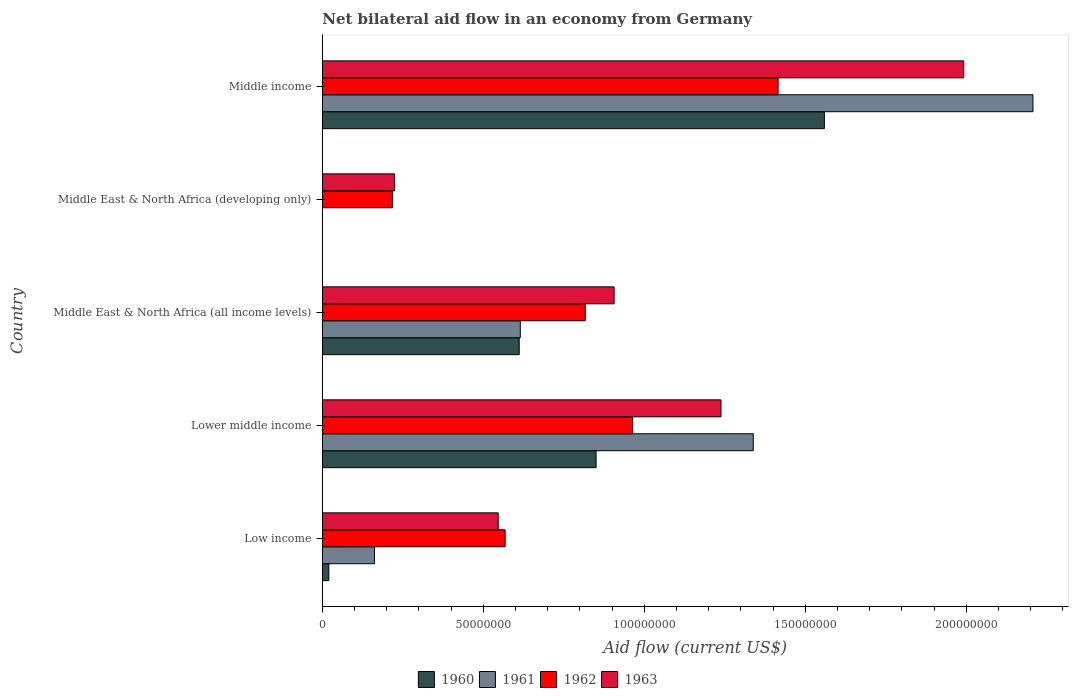How many groups of bars are there?
Offer a terse response. 5. Are the number of bars per tick equal to the number of legend labels?
Offer a terse response. No. Are the number of bars on each tick of the Y-axis equal?
Provide a short and direct response. No. In how many cases, is the number of bars for a given country not equal to the number of legend labels?
Keep it short and to the point. 1. What is the net bilateral aid flow in 1960 in Middle income?
Your answer should be very brief. 1.56e+08. Across all countries, what is the maximum net bilateral aid flow in 1960?
Offer a very short reply. 1.56e+08. Across all countries, what is the minimum net bilateral aid flow in 1963?
Offer a very short reply. 2.24e+07. In which country was the net bilateral aid flow in 1960 maximum?
Provide a succinct answer. Middle income. What is the total net bilateral aid flow in 1961 in the graph?
Offer a terse response. 4.32e+08. What is the difference between the net bilateral aid flow in 1962 in Low income and that in Middle income?
Your answer should be compact. -8.48e+07. What is the difference between the net bilateral aid flow in 1961 in Lower middle income and the net bilateral aid flow in 1963 in Low income?
Provide a short and direct response. 7.92e+07. What is the average net bilateral aid flow in 1962 per country?
Offer a terse response. 7.96e+07. What is the difference between the net bilateral aid flow in 1962 and net bilateral aid flow in 1960 in Middle East & North Africa (all income levels)?
Make the answer very short. 2.05e+07. What is the ratio of the net bilateral aid flow in 1960 in Lower middle income to that in Middle East & North Africa (all income levels)?
Provide a short and direct response. 1.39. Is the difference between the net bilateral aid flow in 1962 in Lower middle income and Middle East & North Africa (all income levels) greater than the difference between the net bilateral aid flow in 1960 in Lower middle income and Middle East & North Africa (all income levels)?
Offer a terse response. No. What is the difference between the highest and the second highest net bilateral aid flow in 1962?
Give a very brief answer. 4.52e+07. What is the difference between the highest and the lowest net bilateral aid flow in 1963?
Give a very brief answer. 1.77e+08. In how many countries, is the net bilateral aid flow in 1963 greater than the average net bilateral aid flow in 1963 taken over all countries?
Make the answer very short. 2. Is the sum of the net bilateral aid flow in 1962 in Low income and Middle East & North Africa (all income levels) greater than the maximum net bilateral aid flow in 1960 across all countries?
Provide a succinct answer. No. Is it the case that in every country, the sum of the net bilateral aid flow in 1961 and net bilateral aid flow in 1962 is greater than the sum of net bilateral aid flow in 1960 and net bilateral aid flow in 1963?
Give a very brief answer. No. Is it the case that in every country, the sum of the net bilateral aid flow in 1960 and net bilateral aid flow in 1962 is greater than the net bilateral aid flow in 1961?
Provide a succinct answer. Yes. Are all the bars in the graph horizontal?
Ensure brevity in your answer.  Yes. What is the difference between two consecutive major ticks on the X-axis?
Your response must be concise. 5.00e+07. Where does the legend appear in the graph?
Your answer should be very brief. Bottom center. How many legend labels are there?
Offer a terse response. 4. How are the legend labels stacked?
Your response must be concise. Horizontal. What is the title of the graph?
Make the answer very short. Net bilateral aid flow in an economy from Germany. Does "1995" appear as one of the legend labels in the graph?
Give a very brief answer. No. What is the label or title of the X-axis?
Your answer should be compact. Aid flow (current US$). What is the Aid flow (current US$) in 1960 in Low income?
Your answer should be very brief. 2.02e+06. What is the Aid flow (current US$) of 1961 in Low income?
Ensure brevity in your answer.  1.62e+07. What is the Aid flow (current US$) in 1962 in Low income?
Ensure brevity in your answer.  5.68e+07. What is the Aid flow (current US$) of 1963 in Low income?
Offer a very short reply. 5.46e+07. What is the Aid flow (current US$) in 1960 in Lower middle income?
Your answer should be compact. 8.50e+07. What is the Aid flow (current US$) in 1961 in Lower middle income?
Your answer should be compact. 1.34e+08. What is the Aid flow (current US$) of 1962 in Lower middle income?
Your response must be concise. 9.64e+07. What is the Aid flow (current US$) of 1963 in Lower middle income?
Your answer should be compact. 1.24e+08. What is the Aid flow (current US$) in 1960 in Middle East & North Africa (all income levels)?
Your response must be concise. 6.11e+07. What is the Aid flow (current US$) in 1961 in Middle East & North Africa (all income levels)?
Make the answer very short. 6.15e+07. What is the Aid flow (current US$) in 1962 in Middle East & North Africa (all income levels)?
Offer a terse response. 8.16e+07. What is the Aid flow (current US$) of 1963 in Middle East & North Africa (all income levels)?
Make the answer very short. 9.06e+07. What is the Aid flow (current US$) of 1962 in Middle East & North Africa (developing only)?
Ensure brevity in your answer.  2.18e+07. What is the Aid flow (current US$) in 1963 in Middle East & North Africa (developing only)?
Provide a succinct answer. 2.24e+07. What is the Aid flow (current US$) of 1960 in Middle income?
Give a very brief answer. 1.56e+08. What is the Aid flow (current US$) of 1961 in Middle income?
Provide a succinct answer. 2.21e+08. What is the Aid flow (current US$) of 1962 in Middle income?
Provide a succinct answer. 1.42e+08. What is the Aid flow (current US$) of 1963 in Middle income?
Provide a short and direct response. 1.99e+08. Across all countries, what is the maximum Aid flow (current US$) in 1960?
Provide a succinct answer. 1.56e+08. Across all countries, what is the maximum Aid flow (current US$) in 1961?
Make the answer very short. 2.21e+08. Across all countries, what is the maximum Aid flow (current US$) of 1962?
Keep it short and to the point. 1.42e+08. Across all countries, what is the maximum Aid flow (current US$) in 1963?
Make the answer very short. 1.99e+08. Across all countries, what is the minimum Aid flow (current US$) of 1960?
Make the answer very short. 0. Across all countries, what is the minimum Aid flow (current US$) of 1961?
Offer a terse response. 0. Across all countries, what is the minimum Aid flow (current US$) of 1962?
Your response must be concise. 2.18e+07. Across all countries, what is the minimum Aid flow (current US$) of 1963?
Keep it short and to the point. 2.24e+07. What is the total Aid flow (current US$) of 1960 in the graph?
Offer a terse response. 3.04e+08. What is the total Aid flow (current US$) in 1961 in the graph?
Provide a succinct answer. 4.32e+08. What is the total Aid flow (current US$) of 1962 in the graph?
Give a very brief answer. 3.98e+08. What is the total Aid flow (current US$) of 1963 in the graph?
Provide a short and direct response. 4.91e+08. What is the difference between the Aid flow (current US$) in 1960 in Low income and that in Lower middle income?
Provide a succinct answer. -8.30e+07. What is the difference between the Aid flow (current US$) in 1961 in Low income and that in Lower middle income?
Your response must be concise. -1.18e+08. What is the difference between the Aid flow (current US$) in 1962 in Low income and that in Lower middle income?
Offer a very short reply. -3.96e+07. What is the difference between the Aid flow (current US$) in 1963 in Low income and that in Lower middle income?
Offer a very short reply. -6.92e+07. What is the difference between the Aid flow (current US$) of 1960 in Low income and that in Middle East & North Africa (all income levels)?
Provide a succinct answer. -5.91e+07. What is the difference between the Aid flow (current US$) in 1961 in Low income and that in Middle East & North Africa (all income levels)?
Your response must be concise. -4.53e+07. What is the difference between the Aid flow (current US$) in 1962 in Low income and that in Middle East & North Africa (all income levels)?
Give a very brief answer. -2.49e+07. What is the difference between the Aid flow (current US$) in 1963 in Low income and that in Middle East & North Africa (all income levels)?
Make the answer very short. -3.60e+07. What is the difference between the Aid flow (current US$) of 1962 in Low income and that in Middle East & North Africa (developing only)?
Provide a succinct answer. 3.50e+07. What is the difference between the Aid flow (current US$) in 1963 in Low income and that in Middle East & North Africa (developing only)?
Provide a succinct answer. 3.22e+07. What is the difference between the Aid flow (current US$) of 1960 in Low income and that in Middle income?
Your answer should be compact. -1.54e+08. What is the difference between the Aid flow (current US$) of 1961 in Low income and that in Middle income?
Your answer should be compact. -2.04e+08. What is the difference between the Aid flow (current US$) in 1962 in Low income and that in Middle income?
Provide a succinct answer. -8.48e+07. What is the difference between the Aid flow (current US$) of 1963 in Low income and that in Middle income?
Make the answer very short. -1.45e+08. What is the difference between the Aid flow (current US$) of 1960 in Lower middle income and that in Middle East & North Africa (all income levels)?
Provide a short and direct response. 2.39e+07. What is the difference between the Aid flow (current US$) of 1961 in Lower middle income and that in Middle East & North Africa (all income levels)?
Offer a very short reply. 7.24e+07. What is the difference between the Aid flow (current US$) of 1962 in Lower middle income and that in Middle East & North Africa (all income levels)?
Provide a short and direct response. 1.47e+07. What is the difference between the Aid flow (current US$) of 1963 in Lower middle income and that in Middle East & North Africa (all income levels)?
Provide a short and direct response. 3.32e+07. What is the difference between the Aid flow (current US$) of 1962 in Lower middle income and that in Middle East & North Africa (developing only)?
Offer a very short reply. 7.46e+07. What is the difference between the Aid flow (current US$) in 1963 in Lower middle income and that in Middle East & North Africa (developing only)?
Offer a terse response. 1.01e+08. What is the difference between the Aid flow (current US$) of 1960 in Lower middle income and that in Middle income?
Ensure brevity in your answer.  -7.09e+07. What is the difference between the Aid flow (current US$) of 1961 in Lower middle income and that in Middle income?
Your answer should be very brief. -8.69e+07. What is the difference between the Aid flow (current US$) in 1962 in Lower middle income and that in Middle income?
Your response must be concise. -4.52e+07. What is the difference between the Aid flow (current US$) of 1963 in Lower middle income and that in Middle income?
Offer a terse response. -7.54e+07. What is the difference between the Aid flow (current US$) in 1962 in Middle East & North Africa (all income levels) and that in Middle East & North Africa (developing only)?
Your answer should be compact. 5.99e+07. What is the difference between the Aid flow (current US$) of 1963 in Middle East & North Africa (all income levels) and that in Middle East & North Africa (developing only)?
Your answer should be very brief. 6.82e+07. What is the difference between the Aid flow (current US$) in 1960 in Middle East & North Africa (all income levels) and that in Middle income?
Your answer should be very brief. -9.48e+07. What is the difference between the Aid flow (current US$) of 1961 in Middle East & North Africa (all income levels) and that in Middle income?
Offer a terse response. -1.59e+08. What is the difference between the Aid flow (current US$) in 1962 in Middle East & North Africa (all income levels) and that in Middle income?
Provide a succinct answer. -5.99e+07. What is the difference between the Aid flow (current US$) of 1963 in Middle East & North Africa (all income levels) and that in Middle income?
Your answer should be very brief. -1.09e+08. What is the difference between the Aid flow (current US$) in 1962 in Middle East & North Africa (developing only) and that in Middle income?
Your answer should be very brief. -1.20e+08. What is the difference between the Aid flow (current US$) in 1963 in Middle East & North Africa (developing only) and that in Middle income?
Ensure brevity in your answer.  -1.77e+08. What is the difference between the Aid flow (current US$) in 1960 in Low income and the Aid flow (current US$) in 1961 in Lower middle income?
Keep it short and to the point. -1.32e+08. What is the difference between the Aid flow (current US$) of 1960 in Low income and the Aid flow (current US$) of 1962 in Lower middle income?
Give a very brief answer. -9.43e+07. What is the difference between the Aid flow (current US$) in 1960 in Low income and the Aid flow (current US$) in 1963 in Lower middle income?
Provide a short and direct response. -1.22e+08. What is the difference between the Aid flow (current US$) of 1961 in Low income and the Aid flow (current US$) of 1962 in Lower middle income?
Make the answer very short. -8.02e+07. What is the difference between the Aid flow (current US$) of 1961 in Low income and the Aid flow (current US$) of 1963 in Lower middle income?
Make the answer very short. -1.08e+08. What is the difference between the Aid flow (current US$) in 1962 in Low income and the Aid flow (current US$) in 1963 in Lower middle income?
Offer a very short reply. -6.70e+07. What is the difference between the Aid flow (current US$) in 1960 in Low income and the Aid flow (current US$) in 1961 in Middle East & North Africa (all income levels)?
Give a very brief answer. -5.94e+07. What is the difference between the Aid flow (current US$) of 1960 in Low income and the Aid flow (current US$) of 1962 in Middle East & North Africa (all income levels)?
Your answer should be compact. -7.96e+07. What is the difference between the Aid flow (current US$) of 1960 in Low income and the Aid flow (current US$) of 1963 in Middle East & North Africa (all income levels)?
Give a very brief answer. -8.86e+07. What is the difference between the Aid flow (current US$) of 1961 in Low income and the Aid flow (current US$) of 1962 in Middle East & North Africa (all income levels)?
Your answer should be very brief. -6.54e+07. What is the difference between the Aid flow (current US$) of 1961 in Low income and the Aid flow (current US$) of 1963 in Middle East & North Africa (all income levels)?
Provide a succinct answer. -7.44e+07. What is the difference between the Aid flow (current US$) in 1962 in Low income and the Aid flow (current US$) in 1963 in Middle East & North Africa (all income levels)?
Keep it short and to the point. -3.38e+07. What is the difference between the Aid flow (current US$) in 1960 in Low income and the Aid flow (current US$) in 1962 in Middle East & North Africa (developing only)?
Make the answer very short. -1.98e+07. What is the difference between the Aid flow (current US$) of 1960 in Low income and the Aid flow (current US$) of 1963 in Middle East & North Africa (developing only)?
Your answer should be very brief. -2.04e+07. What is the difference between the Aid flow (current US$) in 1961 in Low income and the Aid flow (current US$) in 1962 in Middle East & North Africa (developing only)?
Your answer should be very brief. -5.57e+06. What is the difference between the Aid flow (current US$) of 1961 in Low income and the Aid flow (current US$) of 1963 in Middle East & North Africa (developing only)?
Your answer should be very brief. -6.24e+06. What is the difference between the Aid flow (current US$) in 1962 in Low income and the Aid flow (current US$) in 1963 in Middle East & North Africa (developing only)?
Provide a short and direct response. 3.43e+07. What is the difference between the Aid flow (current US$) in 1960 in Low income and the Aid flow (current US$) in 1961 in Middle income?
Your response must be concise. -2.19e+08. What is the difference between the Aid flow (current US$) of 1960 in Low income and the Aid flow (current US$) of 1962 in Middle income?
Offer a very short reply. -1.40e+08. What is the difference between the Aid flow (current US$) in 1960 in Low income and the Aid flow (current US$) in 1963 in Middle income?
Your response must be concise. -1.97e+08. What is the difference between the Aid flow (current US$) of 1961 in Low income and the Aid flow (current US$) of 1962 in Middle income?
Make the answer very short. -1.25e+08. What is the difference between the Aid flow (current US$) of 1961 in Low income and the Aid flow (current US$) of 1963 in Middle income?
Offer a very short reply. -1.83e+08. What is the difference between the Aid flow (current US$) of 1962 in Low income and the Aid flow (current US$) of 1963 in Middle income?
Offer a very short reply. -1.42e+08. What is the difference between the Aid flow (current US$) of 1960 in Lower middle income and the Aid flow (current US$) of 1961 in Middle East & North Africa (all income levels)?
Offer a very short reply. 2.36e+07. What is the difference between the Aid flow (current US$) of 1960 in Lower middle income and the Aid flow (current US$) of 1962 in Middle East & North Africa (all income levels)?
Ensure brevity in your answer.  3.38e+06. What is the difference between the Aid flow (current US$) in 1960 in Lower middle income and the Aid flow (current US$) in 1963 in Middle East & North Africa (all income levels)?
Provide a succinct answer. -5.59e+06. What is the difference between the Aid flow (current US$) of 1961 in Lower middle income and the Aid flow (current US$) of 1962 in Middle East & North Africa (all income levels)?
Offer a very short reply. 5.22e+07. What is the difference between the Aid flow (current US$) of 1961 in Lower middle income and the Aid flow (current US$) of 1963 in Middle East & North Africa (all income levels)?
Your response must be concise. 4.32e+07. What is the difference between the Aid flow (current US$) in 1962 in Lower middle income and the Aid flow (current US$) in 1963 in Middle East & North Africa (all income levels)?
Provide a short and direct response. 5.75e+06. What is the difference between the Aid flow (current US$) in 1960 in Lower middle income and the Aid flow (current US$) in 1962 in Middle East & North Africa (developing only)?
Ensure brevity in your answer.  6.32e+07. What is the difference between the Aid flow (current US$) in 1960 in Lower middle income and the Aid flow (current US$) in 1963 in Middle East & North Africa (developing only)?
Provide a short and direct response. 6.26e+07. What is the difference between the Aid flow (current US$) in 1961 in Lower middle income and the Aid flow (current US$) in 1962 in Middle East & North Africa (developing only)?
Keep it short and to the point. 1.12e+08. What is the difference between the Aid flow (current US$) in 1961 in Lower middle income and the Aid flow (current US$) in 1963 in Middle East & North Africa (developing only)?
Provide a short and direct response. 1.11e+08. What is the difference between the Aid flow (current US$) in 1962 in Lower middle income and the Aid flow (current US$) in 1963 in Middle East & North Africa (developing only)?
Offer a terse response. 7.39e+07. What is the difference between the Aid flow (current US$) of 1960 in Lower middle income and the Aid flow (current US$) of 1961 in Middle income?
Your answer should be compact. -1.36e+08. What is the difference between the Aid flow (current US$) in 1960 in Lower middle income and the Aid flow (current US$) in 1962 in Middle income?
Ensure brevity in your answer.  -5.65e+07. What is the difference between the Aid flow (current US$) in 1960 in Lower middle income and the Aid flow (current US$) in 1963 in Middle income?
Provide a short and direct response. -1.14e+08. What is the difference between the Aid flow (current US$) in 1961 in Lower middle income and the Aid flow (current US$) in 1962 in Middle income?
Keep it short and to the point. -7.71e+06. What is the difference between the Aid flow (current US$) in 1961 in Lower middle income and the Aid flow (current US$) in 1963 in Middle income?
Give a very brief answer. -6.54e+07. What is the difference between the Aid flow (current US$) of 1962 in Lower middle income and the Aid flow (current US$) of 1963 in Middle income?
Your answer should be very brief. -1.03e+08. What is the difference between the Aid flow (current US$) in 1960 in Middle East & North Africa (all income levels) and the Aid flow (current US$) in 1962 in Middle East & North Africa (developing only)?
Offer a very short reply. 3.94e+07. What is the difference between the Aid flow (current US$) in 1960 in Middle East & North Africa (all income levels) and the Aid flow (current US$) in 1963 in Middle East & North Africa (developing only)?
Offer a very short reply. 3.87e+07. What is the difference between the Aid flow (current US$) of 1961 in Middle East & North Africa (all income levels) and the Aid flow (current US$) of 1962 in Middle East & North Africa (developing only)?
Ensure brevity in your answer.  3.97e+07. What is the difference between the Aid flow (current US$) of 1961 in Middle East & North Africa (all income levels) and the Aid flow (current US$) of 1963 in Middle East & North Africa (developing only)?
Your answer should be compact. 3.90e+07. What is the difference between the Aid flow (current US$) of 1962 in Middle East & North Africa (all income levels) and the Aid flow (current US$) of 1963 in Middle East & North Africa (developing only)?
Your answer should be compact. 5.92e+07. What is the difference between the Aid flow (current US$) in 1960 in Middle East & North Africa (all income levels) and the Aid flow (current US$) in 1961 in Middle income?
Your response must be concise. -1.60e+08. What is the difference between the Aid flow (current US$) of 1960 in Middle East & North Africa (all income levels) and the Aid flow (current US$) of 1962 in Middle income?
Offer a very short reply. -8.04e+07. What is the difference between the Aid flow (current US$) of 1960 in Middle East & North Africa (all income levels) and the Aid flow (current US$) of 1963 in Middle income?
Provide a short and direct response. -1.38e+08. What is the difference between the Aid flow (current US$) of 1961 in Middle East & North Africa (all income levels) and the Aid flow (current US$) of 1962 in Middle income?
Your answer should be very brief. -8.01e+07. What is the difference between the Aid flow (current US$) of 1961 in Middle East & North Africa (all income levels) and the Aid flow (current US$) of 1963 in Middle income?
Give a very brief answer. -1.38e+08. What is the difference between the Aid flow (current US$) of 1962 in Middle East & North Africa (all income levels) and the Aid flow (current US$) of 1963 in Middle income?
Your answer should be compact. -1.18e+08. What is the difference between the Aid flow (current US$) of 1962 in Middle East & North Africa (developing only) and the Aid flow (current US$) of 1963 in Middle income?
Make the answer very short. -1.77e+08. What is the average Aid flow (current US$) in 1960 per country?
Your answer should be very brief. 6.08e+07. What is the average Aid flow (current US$) of 1961 per country?
Offer a terse response. 8.64e+07. What is the average Aid flow (current US$) of 1962 per country?
Your answer should be very brief. 7.96e+07. What is the average Aid flow (current US$) of 1963 per country?
Your answer should be compact. 9.81e+07. What is the difference between the Aid flow (current US$) of 1960 and Aid flow (current US$) of 1961 in Low income?
Give a very brief answer. -1.42e+07. What is the difference between the Aid flow (current US$) in 1960 and Aid flow (current US$) in 1962 in Low income?
Make the answer very short. -5.48e+07. What is the difference between the Aid flow (current US$) in 1960 and Aid flow (current US$) in 1963 in Low income?
Provide a succinct answer. -5.26e+07. What is the difference between the Aid flow (current US$) in 1961 and Aid flow (current US$) in 1962 in Low income?
Keep it short and to the point. -4.06e+07. What is the difference between the Aid flow (current US$) in 1961 and Aid flow (current US$) in 1963 in Low income?
Provide a succinct answer. -3.84e+07. What is the difference between the Aid flow (current US$) of 1962 and Aid flow (current US$) of 1963 in Low income?
Your response must be concise. 2.16e+06. What is the difference between the Aid flow (current US$) in 1960 and Aid flow (current US$) in 1961 in Lower middle income?
Your response must be concise. -4.88e+07. What is the difference between the Aid flow (current US$) of 1960 and Aid flow (current US$) of 1962 in Lower middle income?
Ensure brevity in your answer.  -1.13e+07. What is the difference between the Aid flow (current US$) of 1960 and Aid flow (current US$) of 1963 in Lower middle income?
Provide a succinct answer. -3.88e+07. What is the difference between the Aid flow (current US$) in 1961 and Aid flow (current US$) in 1962 in Lower middle income?
Provide a short and direct response. 3.75e+07. What is the difference between the Aid flow (current US$) in 1961 and Aid flow (current US$) in 1963 in Lower middle income?
Give a very brief answer. 1.00e+07. What is the difference between the Aid flow (current US$) of 1962 and Aid flow (current US$) of 1963 in Lower middle income?
Your answer should be very brief. -2.74e+07. What is the difference between the Aid flow (current US$) in 1960 and Aid flow (current US$) in 1961 in Middle East & North Africa (all income levels)?
Provide a succinct answer. -3.30e+05. What is the difference between the Aid flow (current US$) in 1960 and Aid flow (current US$) in 1962 in Middle East & North Africa (all income levels)?
Offer a very short reply. -2.05e+07. What is the difference between the Aid flow (current US$) of 1960 and Aid flow (current US$) of 1963 in Middle East & North Africa (all income levels)?
Your response must be concise. -2.95e+07. What is the difference between the Aid flow (current US$) of 1961 and Aid flow (current US$) of 1962 in Middle East & North Africa (all income levels)?
Your response must be concise. -2.02e+07. What is the difference between the Aid flow (current US$) in 1961 and Aid flow (current US$) in 1963 in Middle East & North Africa (all income levels)?
Provide a short and direct response. -2.91e+07. What is the difference between the Aid flow (current US$) in 1962 and Aid flow (current US$) in 1963 in Middle East & North Africa (all income levels)?
Offer a very short reply. -8.97e+06. What is the difference between the Aid flow (current US$) of 1962 and Aid flow (current US$) of 1963 in Middle East & North Africa (developing only)?
Provide a short and direct response. -6.70e+05. What is the difference between the Aid flow (current US$) of 1960 and Aid flow (current US$) of 1961 in Middle income?
Offer a terse response. -6.48e+07. What is the difference between the Aid flow (current US$) of 1960 and Aid flow (current US$) of 1962 in Middle income?
Your answer should be very brief. 1.44e+07. What is the difference between the Aid flow (current US$) in 1960 and Aid flow (current US$) in 1963 in Middle income?
Provide a succinct answer. -4.33e+07. What is the difference between the Aid flow (current US$) in 1961 and Aid flow (current US$) in 1962 in Middle income?
Your answer should be very brief. 7.92e+07. What is the difference between the Aid flow (current US$) in 1961 and Aid flow (current US$) in 1963 in Middle income?
Your answer should be very brief. 2.15e+07. What is the difference between the Aid flow (current US$) of 1962 and Aid flow (current US$) of 1963 in Middle income?
Offer a very short reply. -5.76e+07. What is the ratio of the Aid flow (current US$) of 1960 in Low income to that in Lower middle income?
Provide a succinct answer. 0.02. What is the ratio of the Aid flow (current US$) in 1961 in Low income to that in Lower middle income?
Your answer should be compact. 0.12. What is the ratio of the Aid flow (current US$) in 1962 in Low income to that in Lower middle income?
Your answer should be compact. 0.59. What is the ratio of the Aid flow (current US$) in 1963 in Low income to that in Lower middle income?
Your response must be concise. 0.44. What is the ratio of the Aid flow (current US$) of 1960 in Low income to that in Middle East & North Africa (all income levels)?
Your answer should be compact. 0.03. What is the ratio of the Aid flow (current US$) in 1961 in Low income to that in Middle East & North Africa (all income levels)?
Make the answer very short. 0.26. What is the ratio of the Aid flow (current US$) of 1962 in Low income to that in Middle East & North Africa (all income levels)?
Provide a short and direct response. 0.7. What is the ratio of the Aid flow (current US$) of 1963 in Low income to that in Middle East & North Africa (all income levels)?
Your response must be concise. 0.6. What is the ratio of the Aid flow (current US$) of 1962 in Low income to that in Middle East & North Africa (developing only)?
Make the answer very short. 2.61. What is the ratio of the Aid flow (current US$) of 1963 in Low income to that in Middle East & North Africa (developing only)?
Your answer should be very brief. 2.43. What is the ratio of the Aid flow (current US$) of 1960 in Low income to that in Middle income?
Offer a very short reply. 0.01. What is the ratio of the Aid flow (current US$) in 1961 in Low income to that in Middle income?
Offer a very short reply. 0.07. What is the ratio of the Aid flow (current US$) in 1962 in Low income to that in Middle income?
Offer a very short reply. 0.4. What is the ratio of the Aid flow (current US$) of 1963 in Low income to that in Middle income?
Keep it short and to the point. 0.27. What is the ratio of the Aid flow (current US$) of 1960 in Lower middle income to that in Middle East & North Africa (all income levels)?
Your answer should be very brief. 1.39. What is the ratio of the Aid flow (current US$) of 1961 in Lower middle income to that in Middle East & North Africa (all income levels)?
Your answer should be very brief. 2.18. What is the ratio of the Aid flow (current US$) of 1962 in Lower middle income to that in Middle East & North Africa (all income levels)?
Give a very brief answer. 1.18. What is the ratio of the Aid flow (current US$) of 1963 in Lower middle income to that in Middle East & North Africa (all income levels)?
Offer a very short reply. 1.37. What is the ratio of the Aid flow (current US$) of 1962 in Lower middle income to that in Middle East & North Africa (developing only)?
Offer a very short reply. 4.43. What is the ratio of the Aid flow (current US$) of 1963 in Lower middle income to that in Middle East & North Africa (developing only)?
Ensure brevity in your answer.  5.52. What is the ratio of the Aid flow (current US$) in 1960 in Lower middle income to that in Middle income?
Your response must be concise. 0.55. What is the ratio of the Aid flow (current US$) of 1961 in Lower middle income to that in Middle income?
Provide a short and direct response. 0.61. What is the ratio of the Aid flow (current US$) in 1962 in Lower middle income to that in Middle income?
Make the answer very short. 0.68. What is the ratio of the Aid flow (current US$) in 1963 in Lower middle income to that in Middle income?
Give a very brief answer. 0.62. What is the ratio of the Aid flow (current US$) of 1962 in Middle East & North Africa (all income levels) to that in Middle East & North Africa (developing only)?
Your response must be concise. 3.75. What is the ratio of the Aid flow (current US$) in 1963 in Middle East & North Africa (all income levels) to that in Middle East & North Africa (developing only)?
Provide a short and direct response. 4.04. What is the ratio of the Aid flow (current US$) of 1960 in Middle East & North Africa (all income levels) to that in Middle income?
Your answer should be compact. 0.39. What is the ratio of the Aid flow (current US$) of 1961 in Middle East & North Africa (all income levels) to that in Middle income?
Make the answer very short. 0.28. What is the ratio of the Aid flow (current US$) of 1962 in Middle East & North Africa (all income levels) to that in Middle income?
Keep it short and to the point. 0.58. What is the ratio of the Aid flow (current US$) in 1963 in Middle East & North Africa (all income levels) to that in Middle income?
Your response must be concise. 0.45. What is the ratio of the Aid flow (current US$) in 1962 in Middle East & North Africa (developing only) to that in Middle income?
Ensure brevity in your answer.  0.15. What is the ratio of the Aid flow (current US$) in 1963 in Middle East & North Africa (developing only) to that in Middle income?
Keep it short and to the point. 0.11. What is the difference between the highest and the second highest Aid flow (current US$) of 1960?
Ensure brevity in your answer.  7.09e+07. What is the difference between the highest and the second highest Aid flow (current US$) of 1961?
Make the answer very short. 8.69e+07. What is the difference between the highest and the second highest Aid flow (current US$) of 1962?
Your answer should be compact. 4.52e+07. What is the difference between the highest and the second highest Aid flow (current US$) in 1963?
Your answer should be very brief. 7.54e+07. What is the difference between the highest and the lowest Aid flow (current US$) of 1960?
Keep it short and to the point. 1.56e+08. What is the difference between the highest and the lowest Aid flow (current US$) of 1961?
Offer a terse response. 2.21e+08. What is the difference between the highest and the lowest Aid flow (current US$) of 1962?
Ensure brevity in your answer.  1.20e+08. What is the difference between the highest and the lowest Aid flow (current US$) in 1963?
Give a very brief answer. 1.77e+08. 